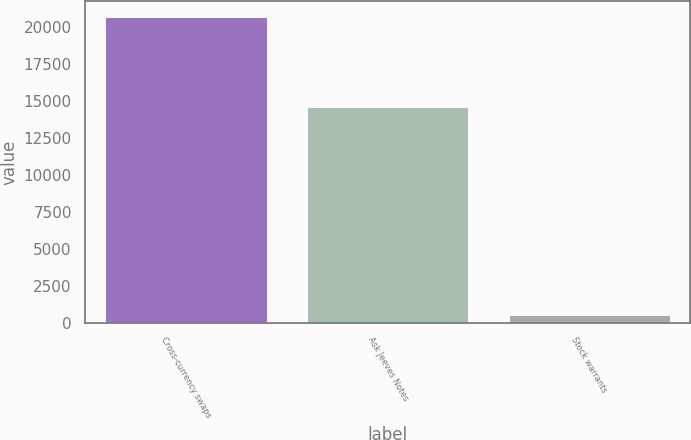<chart> <loc_0><loc_0><loc_500><loc_500><bar_chart><fcel>Cross-currency swaps<fcel>Ask Jeeves Notes<fcel>Stock warrants<nl><fcel>20682<fcel>14600<fcel>500<nl></chart> 